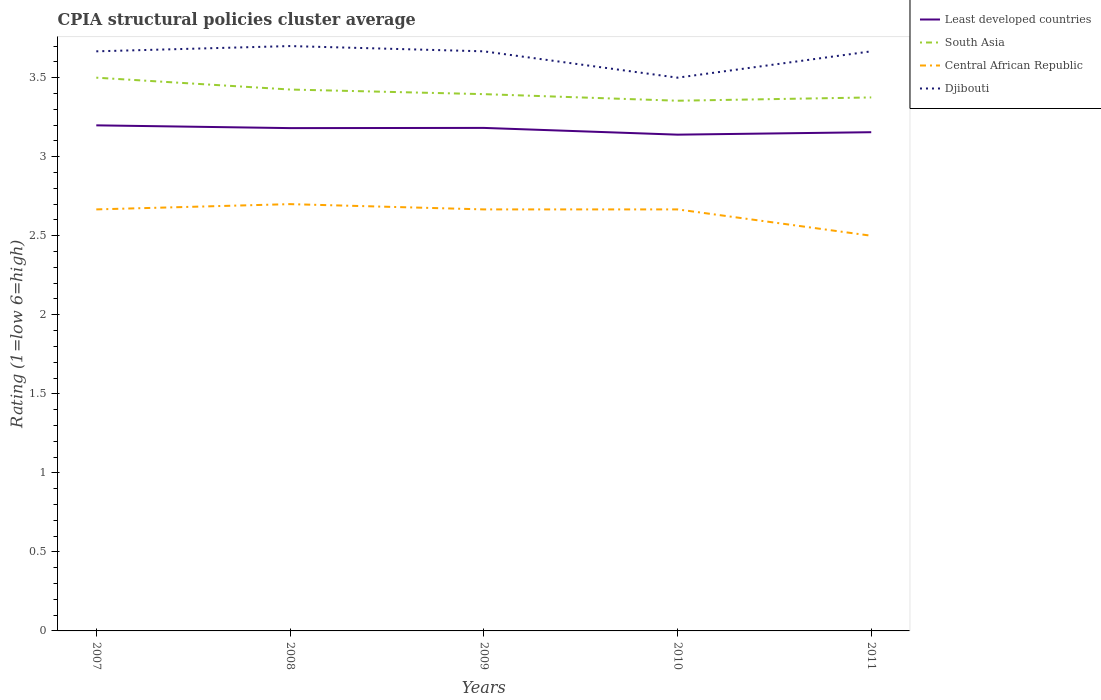Is the number of lines equal to the number of legend labels?
Provide a short and direct response. Yes. Across all years, what is the maximum CPIA rating in Least developed countries?
Provide a short and direct response. 3.14. In which year was the CPIA rating in Central African Republic maximum?
Your answer should be compact. 2011. What is the total CPIA rating in Central African Republic in the graph?
Provide a succinct answer. 0.17. What is the difference between the highest and the second highest CPIA rating in Djibouti?
Offer a terse response. 0.2. What is the difference between the highest and the lowest CPIA rating in Djibouti?
Your answer should be very brief. 4. Is the CPIA rating in Djibouti strictly greater than the CPIA rating in Least developed countries over the years?
Make the answer very short. No. How many years are there in the graph?
Ensure brevity in your answer.  5. Does the graph contain grids?
Offer a terse response. No. Where does the legend appear in the graph?
Your response must be concise. Top right. How are the legend labels stacked?
Give a very brief answer. Vertical. What is the title of the graph?
Provide a succinct answer. CPIA structural policies cluster average. What is the label or title of the Y-axis?
Give a very brief answer. Rating (1=low 6=high). What is the Rating (1=low 6=high) in Least developed countries in 2007?
Ensure brevity in your answer.  3.2. What is the Rating (1=low 6=high) of Central African Republic in 2007?
Give a very brief answer. 2.67. What is the Rating (1=low 6=high) in Djibouti in 2007?
Ensure brevity in your answer.  3.67. What is the Rating (1=low 6=high) of Least developed countries in 2008?
Provide a succinct answer. 3.18. What is the Rating (1=low 6=high) in South Asia in 2008?
Your answer should be compact. 3.42. What is the Rating (1=low 6=high) in Central African Republic in 2008?
Give a very brief answer. 2.7. What is the Rating (1=low 6=high) in Djibouti in 2008?
Provide a succinct answer. 3.7. What is the Rating (1=low 6=high) of Least developed countries in 2009?
Ensure brevity in your answer.  3.18. What is the Rating (1=low 6=high) of South Asia in 2009?
Offer a terse response. 3.4. What is the Rating (1=low 6=high) of Central African Republic in 2009?
Offer a very short reply. 2.67. What is the Rating (1=low 6=high) in Djibouti in 2009?
Give a very brief answer. 3.67. What is the Rating (1=low 6=high) in Least developed countries in 2010?
Your answer should be compact. 3.14. What is the Rating (1=low 6=high) in South Asia in 2010?
Make the answer very short. 3.35. What is the Rating (1=low 6=high) in Central African Republic in 2010?
Offer a terse response. 2.67. What is the Rating (1=low 6=high) of Djibouti in 2010?
Your answer should be compact. 3.5. What is the Rating (1=low 6=high) of Least developed countries in 2011?
Make the answer very short. 3.16. What is the Rating (1=low 6=high) in South Asia in 2011?
Provide a succinct answer. 3.38. What is the Rating (1=low 6=high) in Djibouti in 2011?
Keep it short and to the point. 3.67. Across all years, what is the maximum Rating (1=low 6=high) of Least developed countries?
Your answer should be very brief. 3.2. Across all years, what is the maximum Rating (1=low 6=high) in Djibouti?
Your answer should be compact. 3.7. Across all years, what is the minimum Rating (1=low 6=high) in Least developed countries?
Make the answer very short. 3.14. Across all years, what is the minimum Rating (1=low 6=high) in South Asia?
Your answer should be compact. 3.35. Across all years, what is the minimum Rating (1=low 6=high) in Central African Republic?
Ensure brevity in your answer.  2.5. What is the total Rating (1=low 6=high) of Least developed countries in the graph?
Make the answer very short. 15.86. What is the total Rating (1=low 6=high) of South Asia in the graph?
Offer a terse response. 17.05. What is the difference between the Rating (1=low 6=high) of Least developed countries in 2007 and that in 2008?
Your answer should be compact. 0.02. What is the difference between the Rating (1=low 6=high) of South Asia in 2007 and that in 2008?
Offer a terse response. 0.07. What is the difference between the Rating (1=low 6=high) of Central African Republic in 2007 and that in 2008?
Make the answer very short. -0.03. What is the difference between the Rating (1=low 6=high) in Djibouti in 2007 and that in 2008?
Your response must be concise. -0.03. What is the difference between the Rating (1=low 6=high) in Least developed countries in 2007 and that in 2009?
Provide a short and direct response. 0.02. What is the difference between the Rating (1=low 6=high) in South Asia in 2007 and that in 2009?
Offer a very short reply. 0.1. What is the difference between the Rating (1=low 6=high) of Djibouti in 2007 and that in 2009?
Keep it short and to the point. 0. What is the difference between the Rating (1=low 6=high) in Least developed countries in 2007 and that in 2010?
Provide a short and direct response. 0.06. What is the difference between the Rating (1=low 6=high) in South Asia in 2007 and that in 2010?
Your response must be concise. 0.15. What is the difference between the Rating (1=low 6=high) in Djibouti in 2007 and that in 2010?
Your response must be concise. 0.17. What is the difference between the Rating (1=low 6=high) of Least developed countries in 2007 and that in 2011?
Offer a terse response. 0.04. What is the difference between the Rating (1=low 6=high) of Central African Republic in 2007 and that in 2011?
Offer a terse response. 0.17. What is the difference between the Rating (1=low 6=high) in Djibouti in 2007 and that in 2011?
Provide a succinct answer. 0. What is the difference between the Rating (1=low 6=high) of Least developed countries in 2008 and that in 2009?
Provide a short and direct response. -0. What is the difference between the Rating (1=low 6=high) in South Asia in 2008 and that in 2009?
Your answer should be very brief. 0.03. What is the difference between the Rating (1=low 6=high) in Central African Republic in 2008 and that in 2009?
Your answer should be very brief. 0.03. What is the difference between the Rating (1=low 6=high) in Djibouti in 2008 and that in 2009?
Ensure brevity in your answer.  0.03. What is the difference between the Rating (1=low 6=high) of Least developed countries in 2008 and that in 2010?
Offer a very short reply. 0.04. What is the difference between the Rating (1=low 6=high) of South Asia in 2008 and that in 2010?
Give a very brief answer. 0.07. What is the difference between the Rating (1=low 6=high) in Central African Republic in 2008 and that in 2010?
Provide a succinct answer. 0.03. What is the difference between the Rating (1=low 6=high) in Djibouti in 2008 and that in 2010?
Provide a succinct answer. 0.2. What is the difference between the Rating (1=low 6=high) of Least developed countries in 2008 and that in 2011?
Keep it short and to the point. 0.03. What is the difference between the Rating (1=low 6=high) of Least developed countries in 2009 and that in 2010?
Offer a very short reply. 0.04. What is the difference between the Rating (1=low 6=high) of South Asia in 2009 and that in 2010?
Offer a very short reply. 0.04. What is the difference between the Rating (1=low 6=high) in Central African Republic in 2009 and that in 2010?
Provide a succinct answer. 0. What is the difference between the Rating (1=low 6=high) of Djibouti in 2009 and that in 2010?
Keep it short and to the point. 0.17. What is the difference between the Rating (1=low 6=high) in Least developed countries in 2009 and that in 2011?
Your answer should be compact. 0.03. What is the difference between the Rating (1=low 6=high) in South Asia in 2009 and that in 2011?
Your answer should be compact. 0.02. What is the difference between the Rating (1=low 6=high) of Least developed countries in 2010 and that in 2011?
Your answer should be compact. -0.02. What is the difference between the Rating (1=low 6=high) in South Asia in 2010 and that in 2011?
Your answer should be compact. -0.02. What is the difference between the Rating (1=low 6=high) in Least developed countries in 2007 and the Rating (1=low 6=high) in South Asia in 2008?
Offer a very short reply. -0.23. What is the difference between the Rating (1=low 6=high) of Least developed countries in 2007 and the Rating (1=low 6=high) of Central African Republic in 2008?
Provide a short and direct response. 0.5. What is the difference between the Rating (1=low 6=high) of Least developed countries in 2007 and the Rating (1=low 6=high) of Djibouti in 2008?
Provide a short and direct response. -0.5. What is the difference between the Rating (1=low 6=high) in South Asia in 2007 and the Rating (1=low 6=high) in Central African Republic in 2008?
Keep it short and to the point. 0.8. What is the difference between the Rating (1=low 6=high) in Central African Republic in 2007 and the Rating (1=low 6=high) in Djibouti in 2008?
Ensure brevity in your answer.  -1.03. What is the difference between the Rating (1=low 6=high) in Least developed countries in 2007 and the Rating (1=low 6=high) in South Asia in 2009?
Your answer should be very brief. -0.2. What is the difference between the Rating (1=low 6=high) in Least developed countries in 2007 and the Rating (1=low 6=high) in Central African Republic in 2009?
Ensure brevity in your answer.  0.53. What is the difference between the Rating (1=low 6=high) in Least developed countries in 2007 and the Rating (1=low 6=high) in Djibouti in 2009?
Your answer should be very brief. -0.47. What is the difference between the Rating (1=low 6=high) of South Asia in 2007 and the Rating (1=low 6=high) of Central African Republic in 2009?
Give a very brief answer. 0.83. What is the difference between the Rating (1=low 6=high) in South Asia in 2007 and the Rating (1=low 6=high) in Djibouti in 2009?
Keep it short and to the point. -0.17. What is the difference between the Rating (1=low 6=high) in Central African Republic in 2007 and the Rating (1=low 6=high) in Djibouti in 2009?
Provide a succinct answer. -1. What is the difference between the Rating (1=low 6=high) in Least developed countries in 2007 and the Rating (1=low 6=high) in South Asia in 2010?
Your answer should be compact. -0.16. What is the difference between the Rating (1=low 6=high) in Least developed countries in 2007 and the Rating (1=low 6=high) in Central African Republic in 2010?
Offer a terse response. 0.53. What is the difference between the Rating (1=low 6=high) of Least developed countries in 2007 and the Rating (1=low 6=high) of Djibouti in 2010?
Provide a succinct answer. -0.3. What is the difference between the Rating (1=low 6=high) in South Asia in 2007 and the Rating (1=low 6=high) in Central African Republic in 2010?
Ensure brevity in your answer.  0.83. What is the difference between the Rating (1=low 6=high) of South Asia in 2007 and the Rating (1=low 6=high) of Djibouti in 2010?
Offer a terse response. 0. What is the difference between the Rating (1=low 6=high) of Least developed countries in 2007 and the Rating (1=low 6=high) of South Asia in 2011?
Provide a short and direct response. -0.18. What is the difference between the Rating (1=low 6=high) of Least developed countries in 2007 and the Rating (1=low 6=high) of Central African Republic in 2011?
Your response must be concise. 0.7. What is the difference between the Rating (1=low 6=high) in Least developed countries in 2007 and the Rating (1=low 6=high) in Djibouti in 2011?
Make the answer very short. -0.47. What is the difference between the Rating (1=low 6=high) in South Asia in 2007 and the Rating (1=low 6=high) in Central African Republic in 2011?
Your response must be concise. 1. What is the difference between the Rating (1=low 6=high) of South Asia in 2007 and the Rating (1=low 6=high) of Djibouti in 2011?
Give a very brief answer. -0.17. What is the difference between the Rating (1=low 6=high) in Central African Republic in 2007 and the Rating (1=low 6=high) in Djibouti in 2011?
Your answer should be very brief. -1. What is the difference between the Rating (1=low 6=high) in Least developed countries in 2008 and the Rating (1=low 6=high) in South Asia in 2009?
Provide a short and direct response. -0.21. What is the difference between the Rating (1=low 6=high) in Least developed countries in 2008 and the Rating (1=low 6=high) in Central African Republic in 2009?
Provide a succinct answer. 0.51. What is the difference between the Rating (1=low 6=high) in Least developed countries in 2008 and the Rating (1=low 6=high) in Djibouti in 2009?
Offer a terse response. -0.49. What is the difference between the Rating (1=low 6=high) in South Asia in 2008 and the Rating (1=low 6=high) in Central African Republic in 2009?
Keep it short and to the point. 0.76. What is the difference between the Rating (1=low 6=high) in South Asia in 2008 and the Rating (1=low 6=high) in Djibouti in 2009?
Your response must be concise. -0.24. What is the difference between the Rating (1=low 6=high) in Central African Republic in 2008 and the Rating (1=low 6=high) in Djibouti in 2009?
Provide a succinct answer. -0.97. What is the difference between the Rating (1=low 6=high) of Least developed countries in 2008 and the Rating (1=low 6=high) of South Asia in 2010?
Keep it short and to the point. -0.17. What is the difference between the Rating (1=low 6=high) in Least developed countries in 2008 and the Rating (1=low 6=high) in Central African Republic in 2010?
Offer a very short reply. 0.51. What is the difference between the Rating (1=low 6=high) of Least developed countries in 2008 and the Rating (1=low 6=high) of Djibouti in 2010?
Your answer should be very brief. -0.32. What is the difference between the Rating (1=low 6=high) of South Asia in 2008 and the Rating (1=low 6=high) of Central African Republic in 2010?
Ensure brevity in your answer.  0.76. What is the difference between the Rating (1=low 6=high) in South Asia in 2008 and the Rating (1=low 6=high) in Djibouti in 2010?
Provide a short and direct response. -0.07. What is the difference between the Rating (1=low 6=high) in Central African Republic in 2008 and the Rating (1=low 6=high) in Djibouti in 2010?
Offer a very short reply. -0.8. What is the difference between the Rating (1=low 6=high) in Least developed countries in 2008 and the Rating (1=low 6=high) in South Asia in 2011?
Your answer should be very brief. -0.19. What is the difference between the Rating (1=low 6=high) in Least developed countries in 2008 and the Rating (1=low 6=high) in Central African Republic in 2011?
Ensure brevity in your answer.  0.68. What is the difference between the Rating (1=low 6=high) in Least developed countries in 2008 and the Rating (1=low 6=high) in Djibouti in 2011?
Provide a short and direct response. -0.49. What is the difference between the Rating (1=low 6=high) of South Asia in 2008 and the Rating (1=low 6=high) of Central African Republic in 2011?
Give a very brief answer. 0.93. What is the difference between the Rating (1=low 6=high) in South Asia in 2008 and the Rating (1=low 6=high) in Djibouti in 2011?
Make the answer very short. -0.24. What is the difference between the Rating (1=low 6=high) in Central African Republic in 2008 and the Rating (1=low 6=high) in Djibouti in 2011?
Your response must be concise. -0.97. What is the difference between the Rating (1=low 6=high) in Least developed countries in 2009 and the Rating (1=low 6=high) in South Asia in 2010?
Provide a short and direct response. -0.17. What is the difference between the Rating (1=low 6=high) of Least developed countries in 2009 and the Rating (1=low 6=high) of Central African Republic in 2010?
Make the answer very short. 0.52. What is the difference between the Rating (1=low 6=high) in Least developed countries in 2009 and the Rating (1=low 6=high) in Djibouti in 2010?
Ensure brevity in your answer.  -0.32. What is the difference between the Rating (1=low 6=high) in South Asia in 2009 and the Rating (1=low 6=high) in Central African Republic in 2010?
Provide a succinct answer. 0.73. What is the difference between the Rating (1=low 6=high) in South Asia in 2009 and the Rating (1=low 6=high) in Djibouti in 2010?
Provide a short and direct response. -0.1. What is the difference between the Rating (1=low 6=high) of Least developed countries in 2009 and the Rating (1=low 6=high) of South Asia in 2011?
Your response must be concise. -0.19. What is the difference between the Rating (1=low 6=high) in Least developed countries in 2009 and the Rating (1=low 6=high) in Central African Republic in 2011?
Provide a short and direct response. 0.68. What is the difference between the Rating (1=low 6=high) in Least developed countries in 2009 and the Rating (1=low 6=high) in Djibouti in 2011?
Offer a terse response. -0.48. What is the difference between the Rating (1=low 6=high) in South Asia in 2009 and the Rating (1=low 6=high) in Central African Republic in 2011?
Ensure brevity in your answer.  0.9. What is the difference between the Rating (1=low 6=high) of South Asia in 2009 and the Rating (1=low 6=high) of Djibouti in 2011?
Your response must be concise. -0.27. What is the difference between the Rating (1=low 6=high) in Central African Republic in 2009 and the Rating (1=low 6=high) in Djibouti in 2011?
Your answer should be compact. -1. What is the difference between the Rating (1=low 6=high) in Least developed countries in 2010 and the Rating (1=low 6=high) in South Asia in 2011?
Provide a short and direct response. -0.24. What is the difference between the Rating (1=low 6=high) of Least developed countries in 2010 and the Rating (1=low 6=high) of Central African Republic in 2011?
Offer a terse response. 0.64. What is the difference between the Rating (1=low 6=high) in Least developed countries in 2010 and the Rating (1=low 6=high) in Djibouti in 2011?
Offer a very short reply. -0.53. What is the difference between the Rating (1=low 6=high) in South Asia in 2010 and the Rating (1=low 6=high) in Central African Republic in 2011?
Keep it short and to the point. 0.85. What is the difference between the Rating (1=low 6=high) of South Asia in 2010 and the Rating (1=low 6=high) of Djibouti in 2011?
Offer a terse response. -0.31. What is the average Rating (1=low 6=high) in Least developed countries per year?
Give a very brief answer. 3.17. What is the average Rating (1=low 6=high) in South Asia per year?
Provide a succinct answer. 3.41. What is the average Rating (1=low 6=high) in Central African Republic per year?
Your answer should be compact. 2.64. What is the average Rating (1=low 6=high) of Djibouti per year?
Your answer should be compact. 3.64. In the year 2007, what is the difference between the Rating (1=low 6=high) in Least developed countries and Rating (1=low 6=high) in South Asia?
Keep it short and to the point. -0.3. In the year 2007, what is the difference between the Rating (1=low 6=high) of Least developed countries and Rating (1=low 6=high) of Central African Republic?
Make the answer very short. 0.53. In the year 2007, what is the difference between the Rating (1=low 6=high) of Least developed countries and Rating (1=low 6=high) of Djibouti?
Ensure brevity in your answer.  -0.47. In the year 2007, what is the difference between the Rating (1=low 6=high) in South Asia and Rating (1=low 6=high) in Central African Republic?
Ensure brevity in your answer.  0.83. In the year 2007, what is the difference between the Rating (1=low 6=high) of Central African Republic and Rating (1=low 6=high) of Djibouti?
Give a very brief answer. -1. In the year 2008, what is the difference between the Rating (1=low 6=high) of Least developed countries and Rating (1=low 6=high) of South Asia?
Make the answer very short. -0.24. In the year 2008, what is the difference between the Rating (1=low 6=high) of Least developed countries and Rating (1=low 6=high) of Central African Republic?
Offer a terse response. 0.48. In the year 2008, what is the difference between the Rating (1=low 6=high) in Least developed countries and Rating (1=low 6=high) in Djibouti?
Offer a very short reply. -0.52. In the year 2008, what is the difference between the Rating (1=low 6=high) of South Asia and Rating (1=low 6=high) of Central African Republic?
Give a very brief answer. 0.72. In the year 2008, what is the difference between the Rating (1=low 6=high) in South Asia and Rating (1=low 6=high) in Djibouti?
Provide a short and direct response. -0.28. In the year 2009, what is the difference between the Rating (1=low 6=high) of Least developed countries and Rating (1=low 6=high) of South Asia?
Your answer should be very brief. -0.21. In the year 2009, what is the difference between the Rating (1=low 6=high) in Least developed countries and Rating (1=low 6=high) in Central African Republic?
Ensure brevity in your answer.  0.52. In the year 2009, what is the difference between the Rating (1=low 6=high) in Least developed countries and Rating (1=low 6=high) in Djibouti?
Your answer should be very brief. -0.48. In the year 2009, what is the difference between the Rating (1=low 6=high) in South Asia and Rating (1=low 6=high) in Central African Republic?
Offer a terse response. 0.73. In the year 2009, what is the difference between the Rating (1=low 6=high) of South Asia and Rating (1=low 6=high) of Djibouti?
Your answer should be compact. -0.27. In the year 2010, what is the difference between the Rating (1=low 6=high) of Least developed countries and Rating (1=low 6=high) of South Asia?
Your response must be concise. -0.21. In the year 2010, what is the difference between the Rating (1=low 6=high) in Least developed countries and Rating (1=low 6=high) in Central African Republic?
Ensure brevity in your answer.  0.47. In the year 2010, what is the difference between the Rating (1=low 6=high) in Least developed countries and Rating (1=low 6=high) in Djibouti?
Offer a very short reply. -0.36. In the year 2010, what is the difference between the Rating (1=low 6=high) in South Asia and Rating (1=low 6=high) in Central African Republic?
Give a very brief answer. 0.69. In the year 2010, what is the difference between the Rating (1=low 6=high) of South Asia and Rating (1=low 6=high) of Djibouti?
Make the answer very short. -0.15. In the year 2010, what is the difference between the Rating (1=low 6=high) in Central African Republic and Rating (1=low 6=high) in Djibouti?
Provide a short and direct response. -0.83. In the year 2011, what is the difference between the Rating (1=low 6=high) of Least developed countries and Rating (1=low 6=high) of South Asia?
Provide a short and direct response. -0.22. In the year 2011, what is the difference between the Rating (1=low 6=high) in Least developed countries and Rating (1=low 6=high) in Central African Republic?
Your answer should be very brief. 0.66. In the year 2011, what is the difference between the Rating (1=low 6=high) in Least developed countries and Rating (1=low 6=high) in Djibouti?
Your response must be concise. -0.51. In the year 2011, what is the difference between the Rating (1=low 6=high) of South Asia and Rating (1=low 6=high) of Central African Republic?
Make the answer very short. 0.88. In the year 2011, what is the difference between the Rating (1=low 6=high) in South Asia and Rating (1=low 6=high) in Djibouti?
Provide a succinct answer. -0.29. In the year 2011, what is the difference between the Rating (1=low 6=high) in Central African Republic and Rating (1=low 6=high) in Djibouti?
Your answer should be compact. -1.17. What is the ratio of the Rating (1=low 6=high) in Least developed countries in 2007 to that in 2008?
Offer a very short reply. 1.01. What is the ratio of the Rating (1=low 6=high) in South Asia in 2007 to that in 2008?
Keep it short and to the point. 1.02. What is the ratio of the Rating (1=low 6=high) in Least developed countries in 2007 to that in 2009?
Your answer should be very brief. 1.01. What is the ratio of the Rating (1=low 6=high) in South Asia in 2007 to that in 2009?
Provide a short and direct response. 1.03. What is the ratio of the Rating (1=low 6=high) of Central African Republic in 2007 to that in 2009?
Your response must be concise. 1. What is the ratio of the Rating (1=low 6=high) of Least developed countries in 2007 to that in 2010?
Offer a very short reply. 1.02. What is the ratio of the Rating (1=low 6=high) in South Asia in 2007 to that in 2010?
Your answer should be compact. 1.04. What is the ratio of the Rating (1=low 6=high) of Central African Republic in 2007 to that in 2010?
Ensure brevity in your answer.  1. What is the ratio of the Rating (1=low 6=high) of Djibouti in 2007 to that in 2010?
Your answer should be very brief. 1.05. What is the ratio of the Rating (1=low 6=high) of Least developed countries in 2007 to that in 2011?
Your answer should be compact. 1.01. What is the ratio of the Rating (1=low 6=high) of Central African Republic in 2007 to that in 2011?
Provide a succinct answer. 1.07. What is the ratio of the Rating (1=low 6=high) of Least developed countries in 2008 to that in 2009?
Keep it short and to the point. 1. What is the ratio of the Rating (1=low 6=high) of South Asia in 2008 to that in 2009?
Ensure brevity in your answer.  1.01. What is the ratio of the Rating (1=low 6=high) of Central African Republic in 2008 to that in 2009?
Your answer should be compact. 1.01. What is the ratio of the Rating (1=low 6=high) of Djibouti in 2008 to that in 2009?
Keep it short and to the point. 1.01. What is the ratio of the Rating (1=low 6=high) in Least developed countries in 2008 to that in 2010?
Your answer should be very brief. 1.01. What is the ratio of the Rating (1=low 6=high) in South Asia in 2008 to that in 2010?
Your response must be concise. 1.02. What is the ratio of the Rating (1=low 6=high) in Central African Republic in 2008 to that in 2010?
Ensure brevity in your answer.  1.01. What is the ratio of the Rating (1=low 6=high) in Djibouti in 2008 to that in 2010?
Offer a very short reply. 1.06. What is the ratio of the Rating (1=low 6=high) of Least developed countries in 2008 to that in 2011?
Ensure brevity in your answer.  1.01. What is the ratio of the Rating (1=low 6=high) of South Asia in 2008 to that in 2011?
Make the answer very short. 1.01. What is the ratio of the Rating (1=low 6=high) of Central African Republic in 2008 to that in 2011?
Your answer should be compact. 1.08. What is the ratio of the Rating (1=low 6=high) in Djibouti in 2008 to that in 2011?
Provide a short and direct response. 1.01. What is the ratio of the Rating (1=low 6=high) of Least developed countries in 2009 to that in 2010?
Offer a terse response. 1.01. What is the ratio of the Rating (1=low 6=high) of South Asia in 2009 to that in 2010?
Offer a terse response. 1.01. What is the ratio of the Rating (1=low 6=high) of Central African Republic in 2009 to that in 2010?
Your response must be concise. 1. What is the ratio of the Rating (1=low 6=high) in Djibouti in 2009 to that in 2010?
Your answer should be compact. 1.05. What is the ratio of the Rating (1=low 6=high) of Least developed countries in 2009 to that in 2011?
Keep it short and to the point. 1.01. What is the ratio of the Rating (1=low 6=high) of South Asia in 2009 to that in 2011?
Offer a very short reply. 1.01. What is the ratio of the Rating (1=low 6=high) of Central African Republic in 2009 to that in 2011?
Offer a very short reply. 1.07. What is the ratio of the Rating (1=low 6=high) in South Asia in 2010 to that in 2011?
Keep it short and to the point. 0.99. What is the ratio of the Rating (1=low 6=high) in Central African Republic in 2010 to that in 2011?
Keep it short and to the point. 1.07. What is the ratio of the Rating (1=low 6=high) of Djibouti in 2010 to that in 2011?
Provide a short and direct response. 0.95. What is the difference between the highest and the second highest Rating (1=low 6=high) of Least developed countries?
Provide a short and direct response. 0.02. What is the difference between the highest and the second highest Rating (1=low 6=high) in South Asia?
Make the answer very short. 0.07. What is the difference between the highest and the lowest Rating (1=low 6=high) in Least developed countries?
Provide a succinct answer. 0.06. What is the difference between the highest and the lowest Rating (1=low 6=high) in South Asia?
Provide a succinct answer. 0.15. What is the difference between the highest and the lowest Rating (1=low 6=high) in Central African Republic?
Provide a short and direct response. 0.2. 